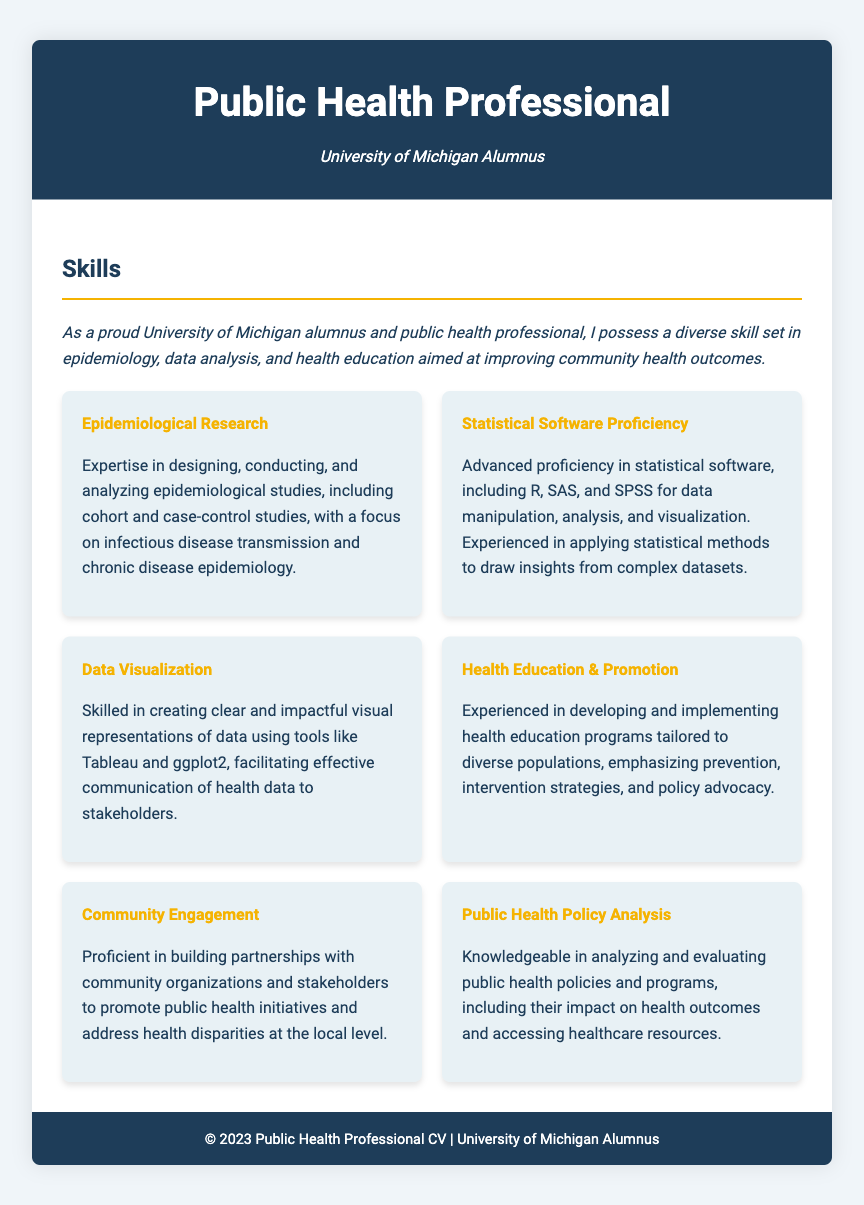what is the focus of the skills section? The skills section focuses on improving community health outcomes through expertise in specific areas.
Answer: improving community health outcomes how many skill areas are listed? There are six distinct skill areas listed within the skills section of the CV.
Answer: six which statistical software is mentioned? The CV mentions R, SAS, and SPSS as the statistical software being utilized.
Answer: R, SAS, and SPSS what type of studies does the epidemiological research skill encompass? The epidemiological research skill encompasses cohort and case-control studies.
Answer: cohort and case-control studies what is emphasized in the health education and promotion skill? The health education and promotion skill emphasizes prevention and intervention strategies.
Answer: prevention and intervention strategies which skill involves creating visual representations of data? The skill that involves creating visual representations of data is Data Visualization.
Answer: Data Visualization what organization does the CV highlight for community engagement? The CV highlights partnerships with community organizations and stakeholders for community engagement.
Answer: community organizations and stakeholders what is the educational background highlighted in the header? The educational background highlighted in the header is an alumnus of the University of Michigan.
Answer: University of Michigan Alumnus what health aspect does the Public Health Policy Analysis skill analyze? The Public Health Policy Analysis skill analyzes the impact of public health policies on health outcomes.
Answer: health outcomes 